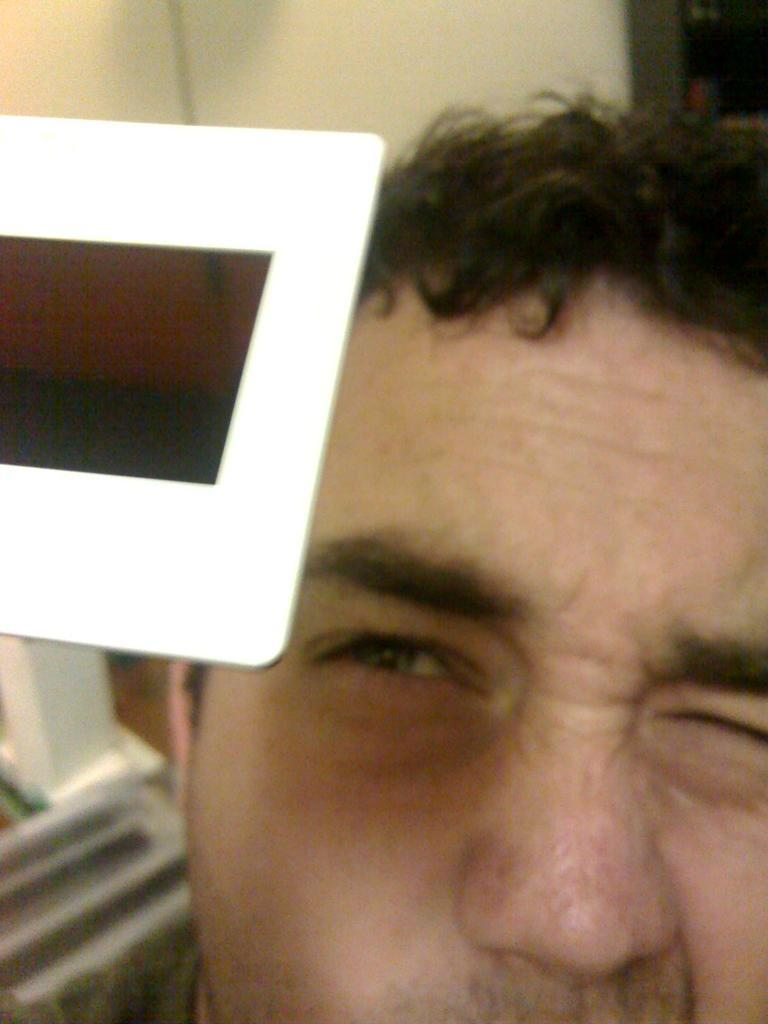What is the main subject of the image? The main subject of the image is a person's face. Can you describe anything else in the image besides the person's face? Yes, there is an object on the left side of the image. What grade did the person receive on their recent exam, as shown in the image? There is no information about an exam or a grade in the image. 